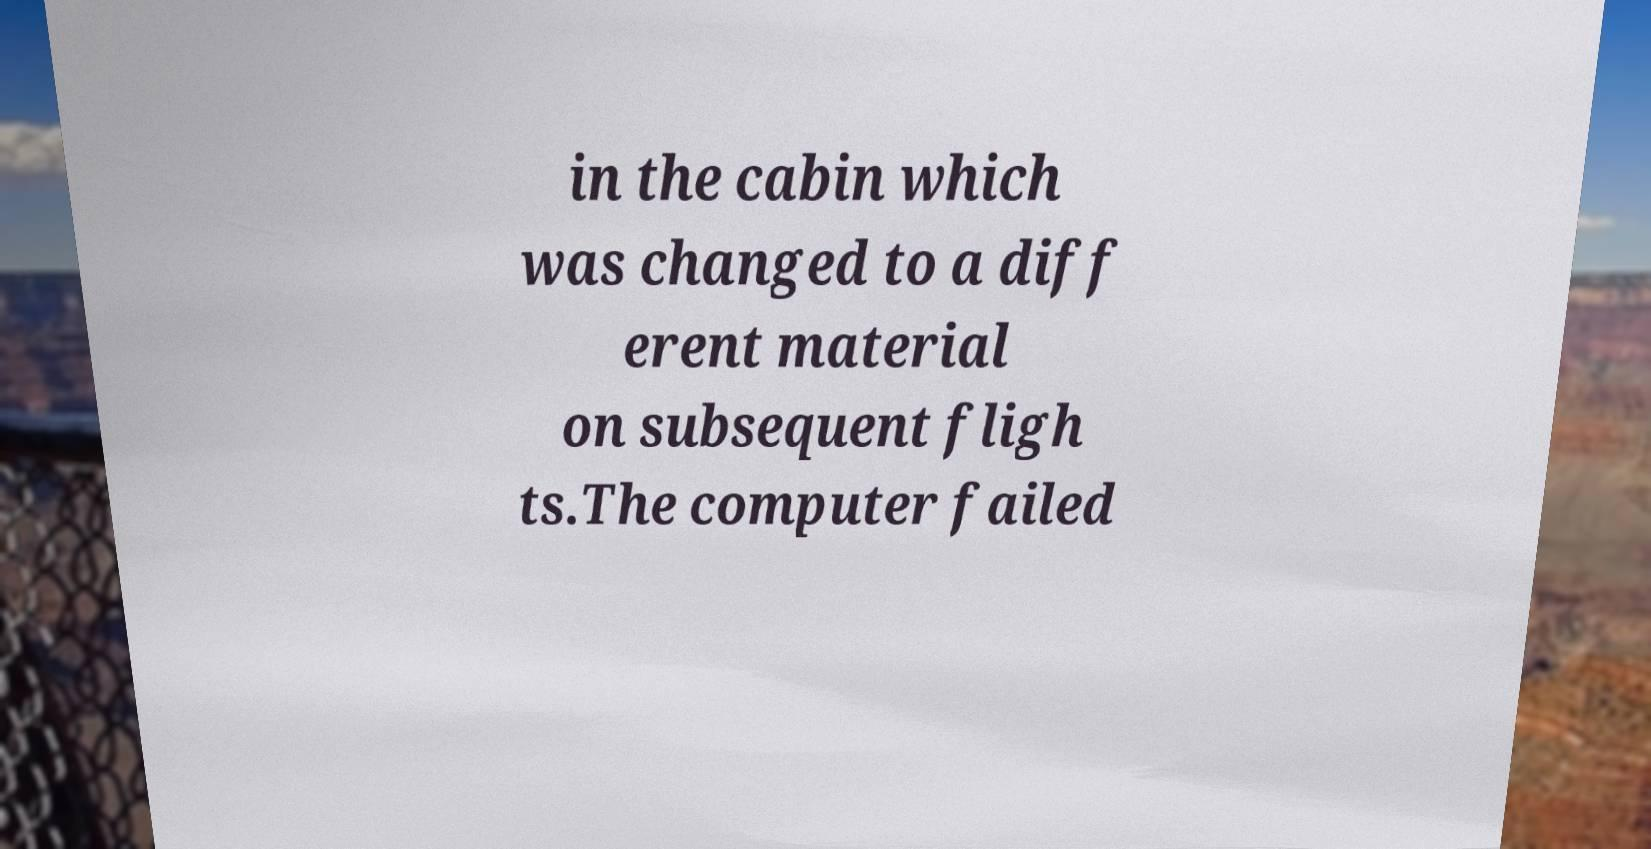Can you accurately transcribe the text from the provided image for me? in the cabin which was changed to a diff erent material on subsequent fligh ts.The computer failed 